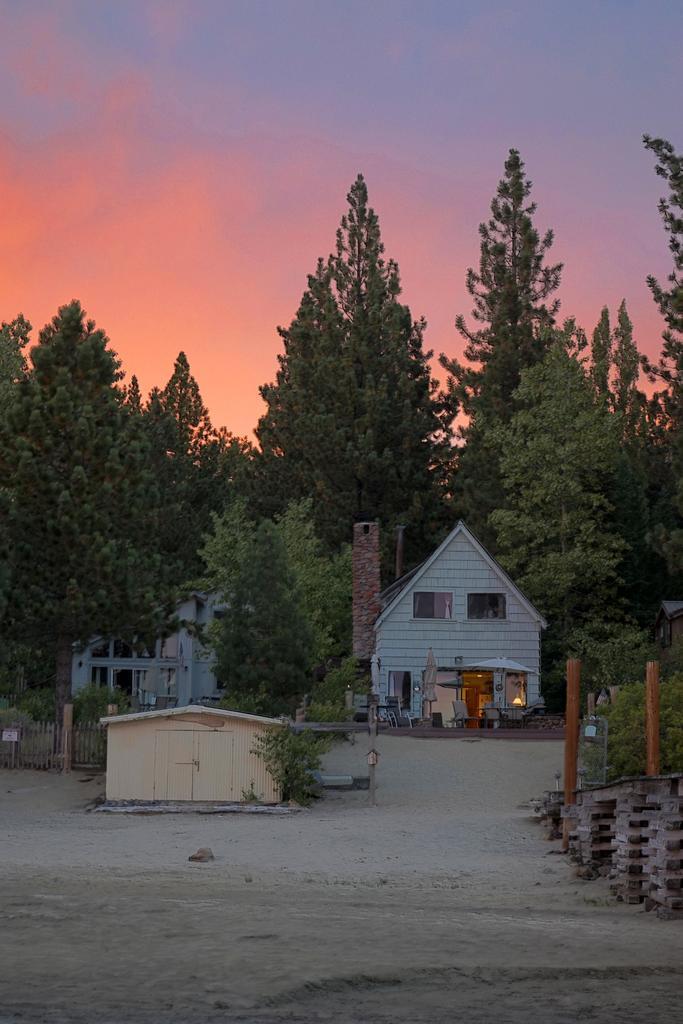In one or two sentences, can you explain what this image depicts? In this picture we can see few houses, around we can see trees and land. 